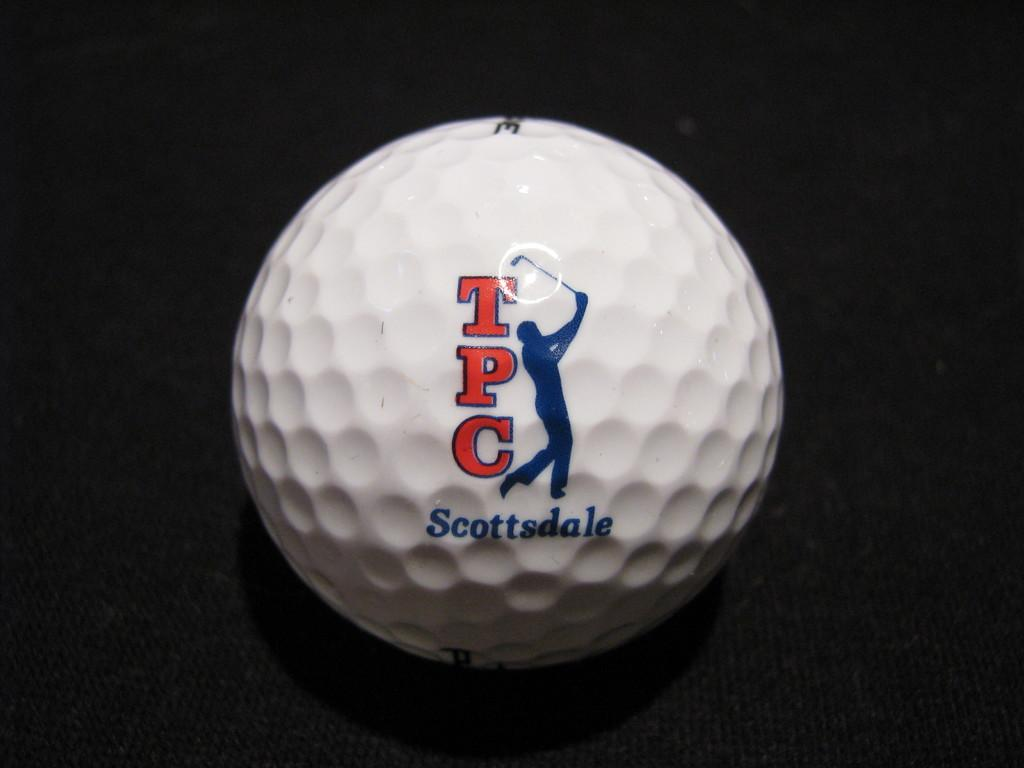<image>
Relay a brief, clear account of the picture shown. The white golf ball is from TPC Scottsdale. 